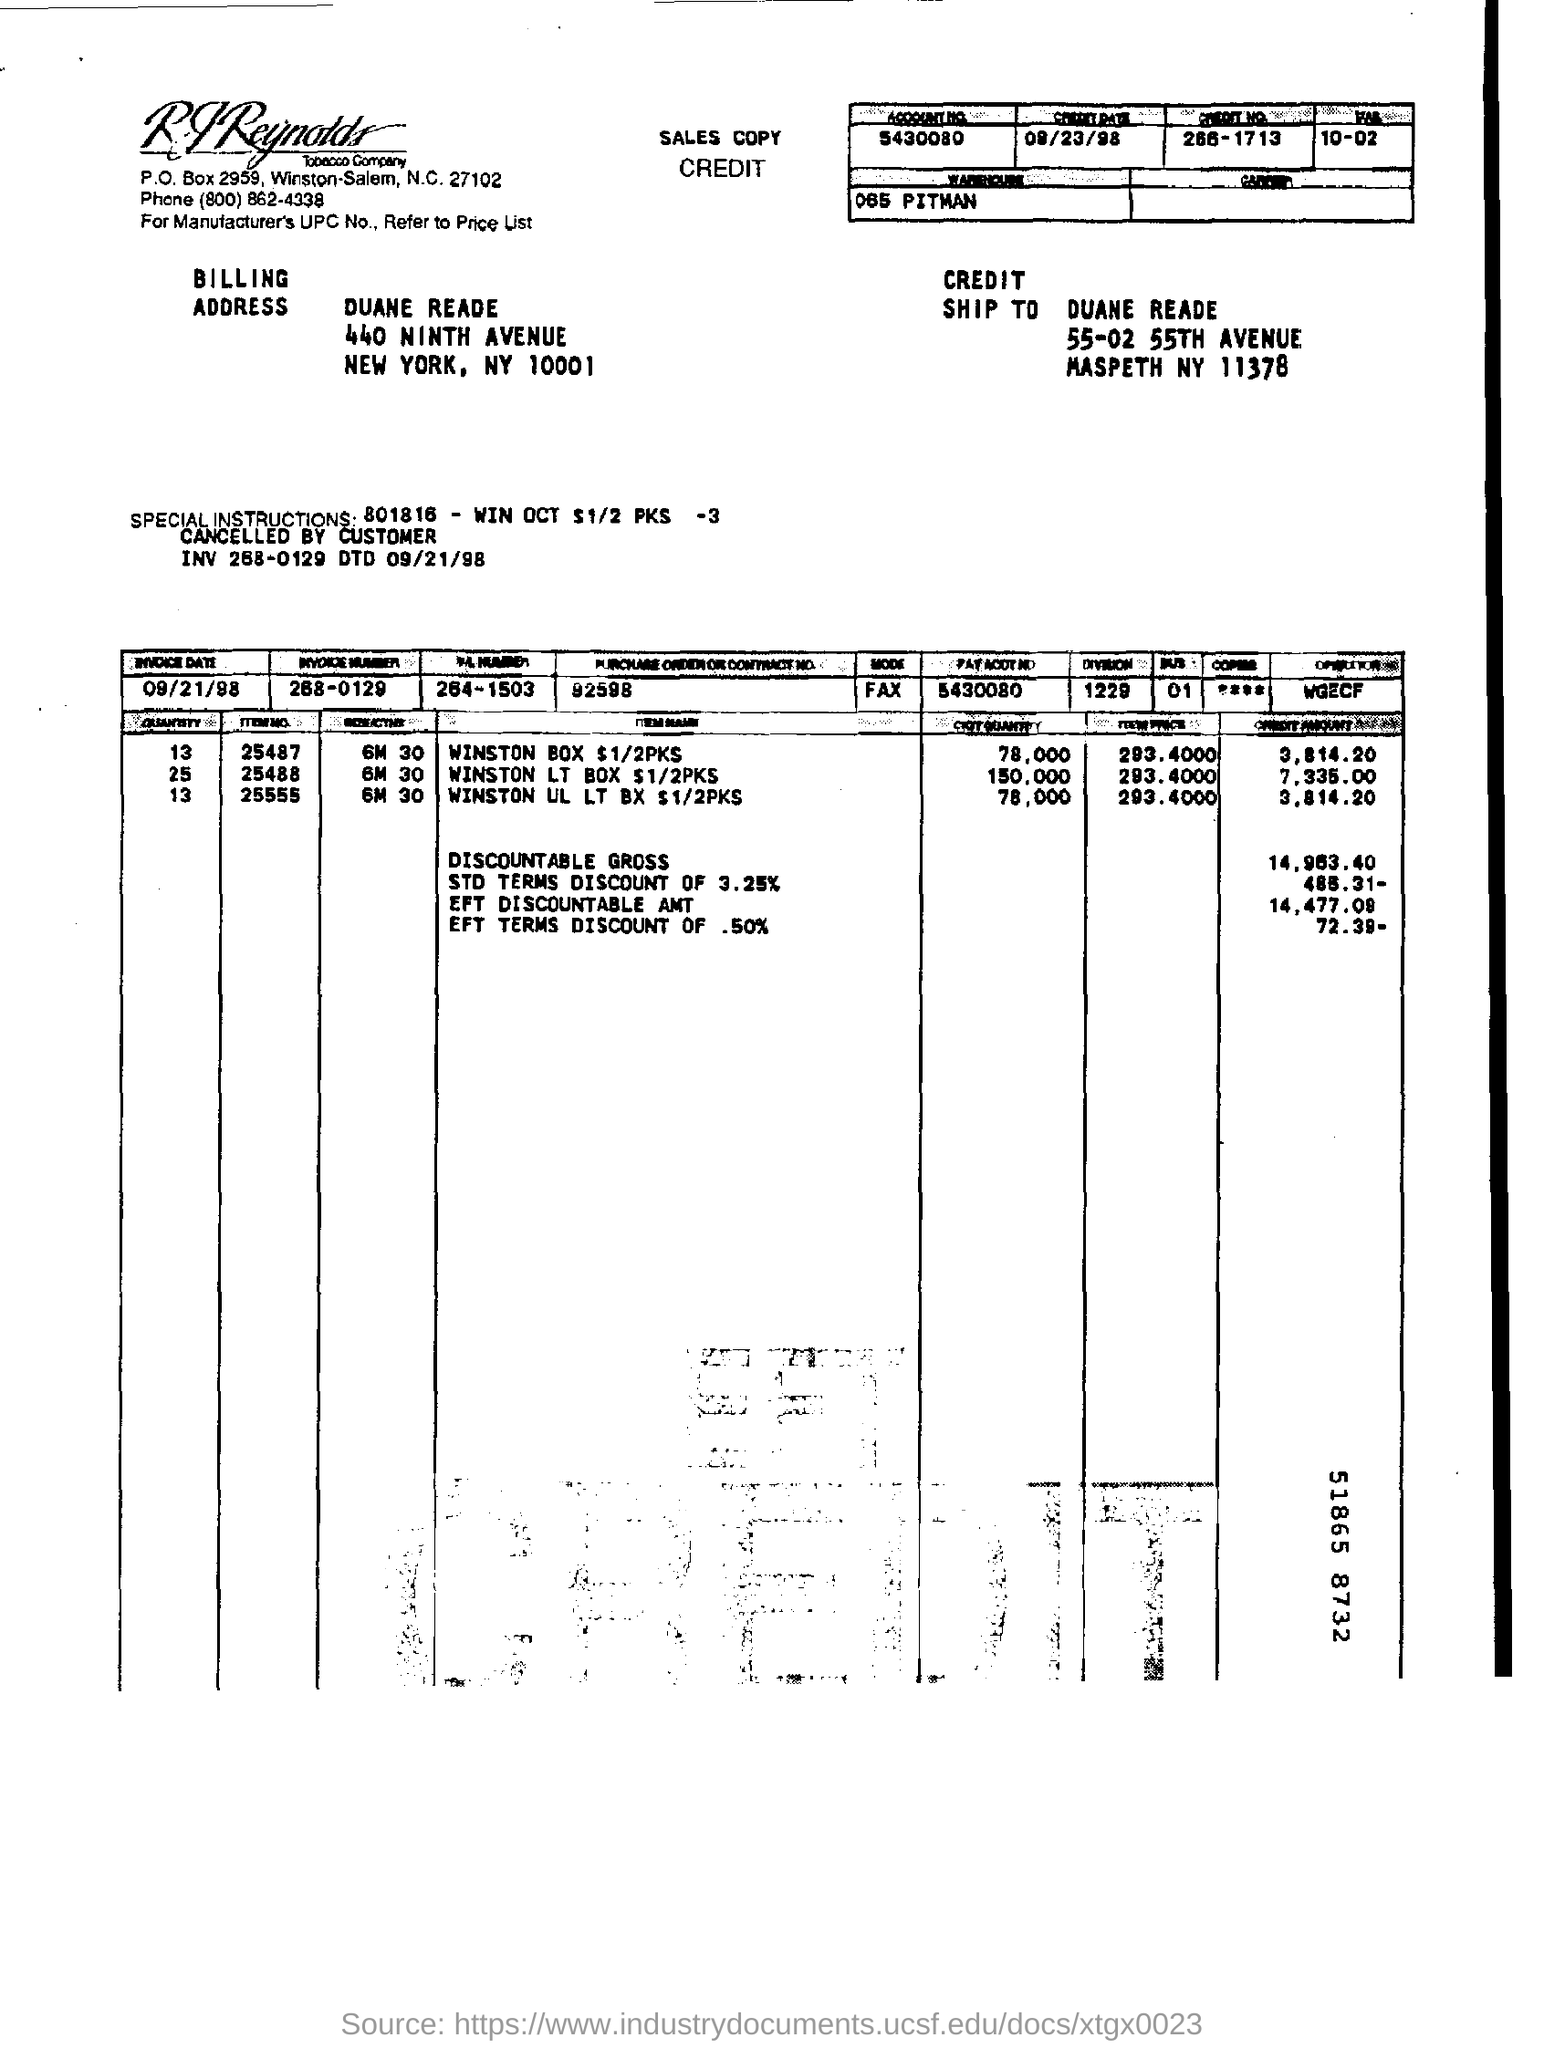What is the account no ?
Your response must be concise. 5430080. What is the credit date ?
Ensure brevity in your answer.  09/23/98. What is the credit no ?
Provide a succinct answer. 266-1713. What is the invoice date ?
Ensure brevity in your answer.  09/21/98. What is the invoice number ?
Your answer should be compact. 268-0129. 